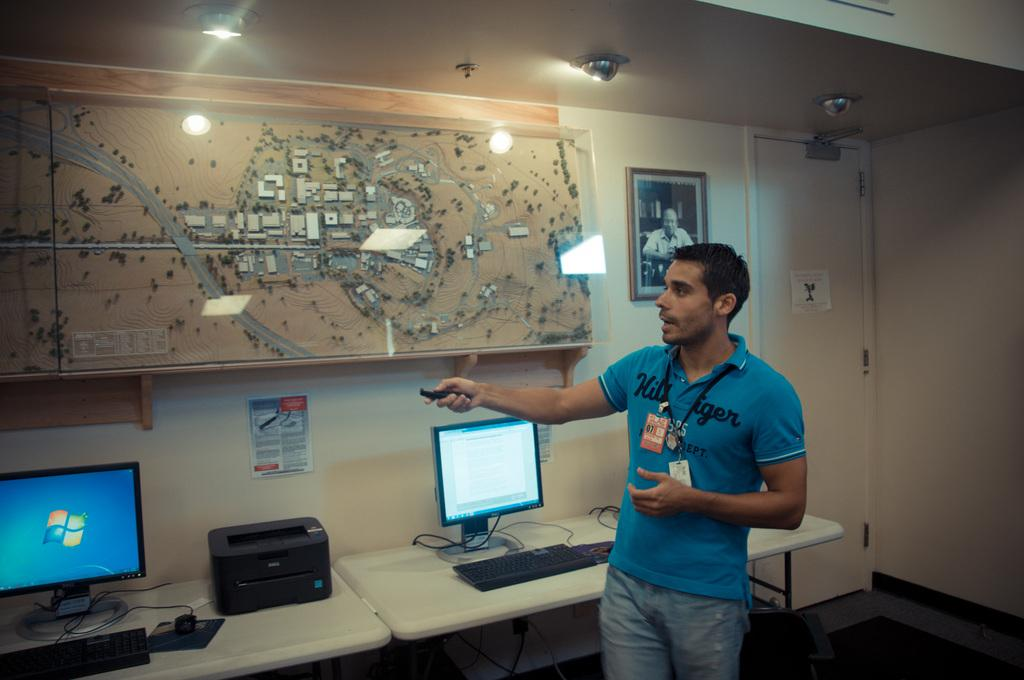<image>
Summarize the visual content of the image. a man talking about a display while wearing a blue hillfiger shirt 